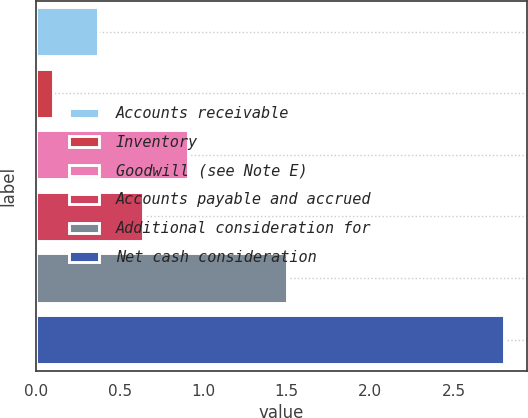<chart> <loc_0><loc_0><loc_500><loc_500><bar_chart><fcel>Accounts receivable<fcel>Inventory<fcel>Goodwill (see Note E)<fcel>Accounts payable and accrued<fcel>Additional consideration for<fcel>Net cash consideration<nl><fcel>0.37<fcel>0.1<fcel>0.91<fcel>0.64<fcel>1.5<fcel>2.8<nl></chart> 